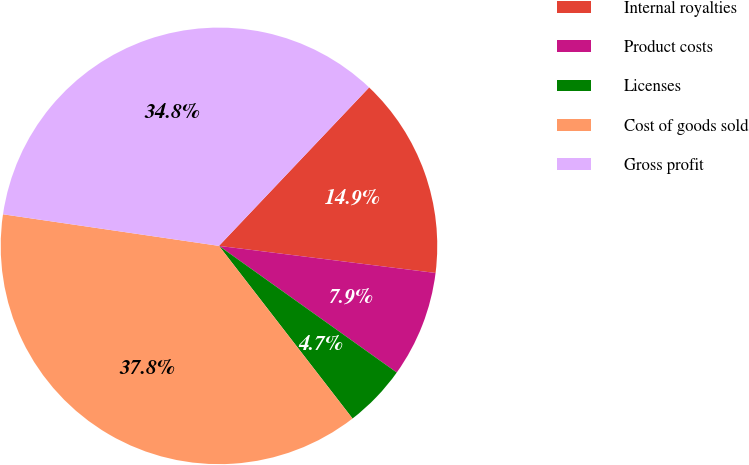<chart> <loc_0><loc_0><loc_500><loc_500><pie_chart><fcel>Internal royalties<fcel>Product costs<fcel>Licenses<fcel>Cost of goods sold<fcel>Gross profit<nl><fcel>14.91%<fcel>7.87%<fcel>4.67%<fcel>37.79%<fcel>34.76%<nl></chart> 